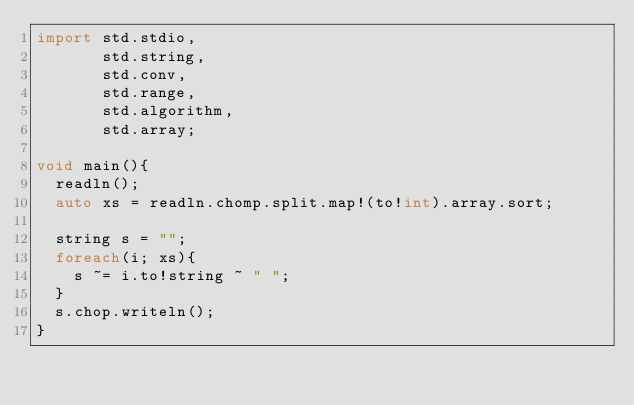Convert code to text. <code><loc_0><loc_0><loc_500><loc_500><_D_>import std.stdio,
       std.string,
       std.conv,
       std.range,
       std.algorithm,
       std.array;

void main(){
	readln();
	auto xs = readln.chomp.split.map!(to!int).array.sort;

	string s = "";
	foreach(i; xs){
		s ~= i.to!string ~ " ";
	}
	s.chop.writeln();
}</code> 